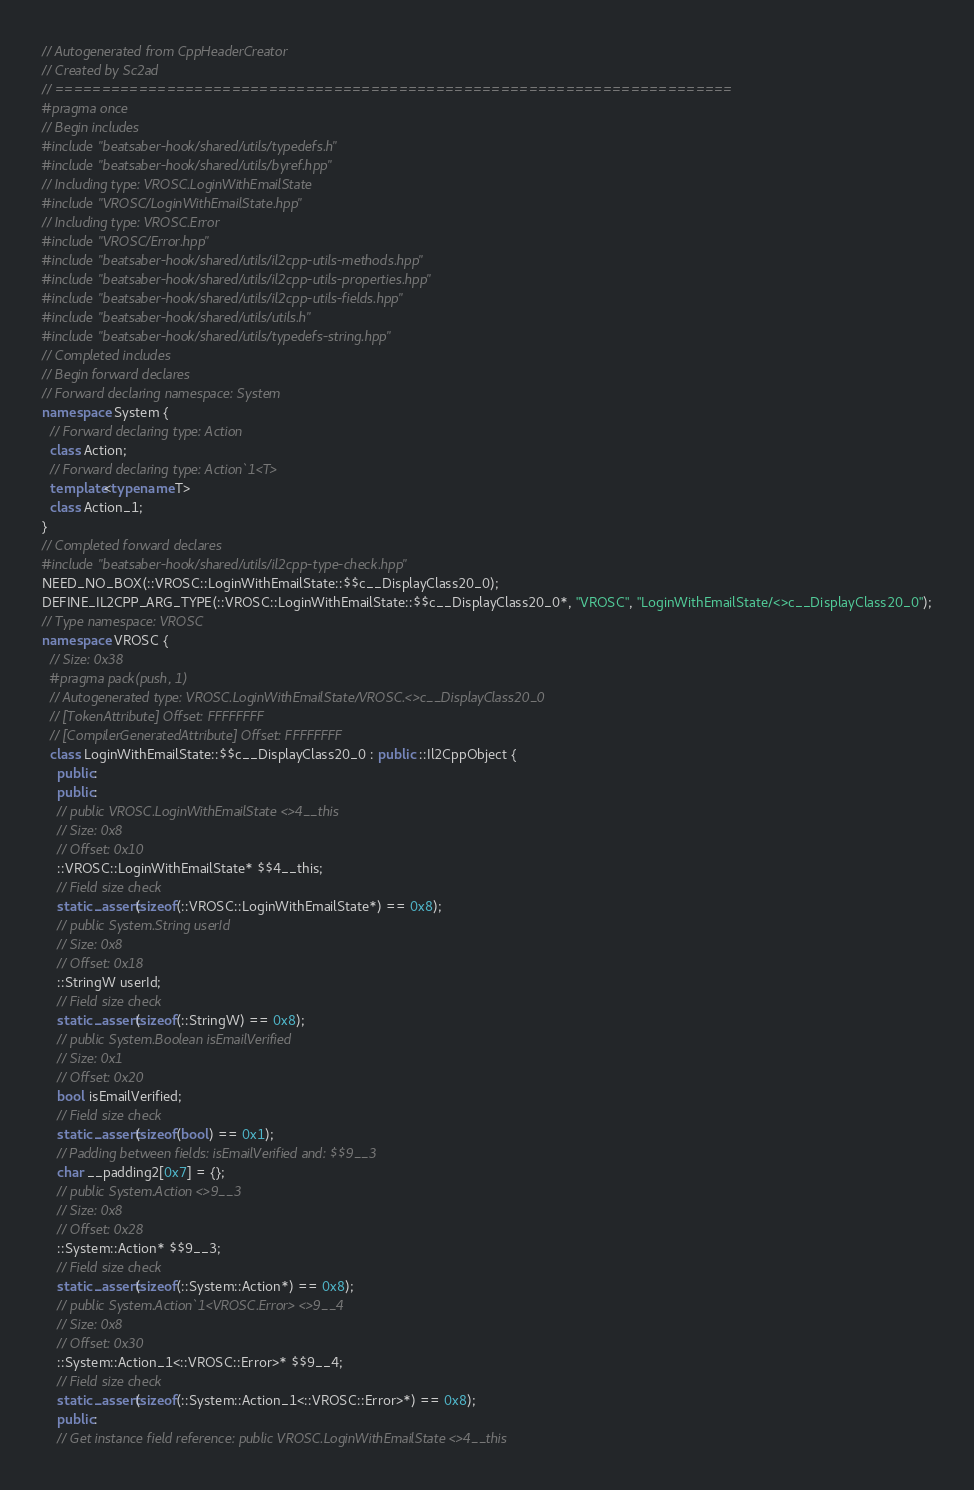<code> <loc_0><loc_0><loc_500><loc_500><_C++_>// Autogenerated from CppHeaderCreator
// Created by Sc2ad
// =========================================================================
#pragma once
// Begin includes
#include "beatsaber-hook/shared/utils/typedefs.h"
#include "beatsaber-hook/shared/utils/byref.hpp"
// Including type: VROSC.LoginWithEmailState
#include "VROSC/LoginWithEmailState.hpp"
// Including type: VROSC.Error
#include "VROSC/Error.hpp"
#include "beatsaber-hook/shared/utils/il2cpp-utils-methods.hpp"
#include "beatsaber-hook/shared/utils/il2cpp-utils-properties.hpp"
#include "beatsaber-hook/shared/utils/il2cpp-utils-fields.hpp"
#include "beatsaber-hook/shared/utils/utils.h"
#include "beatsaber-hook/shared/utils/typedefs-string.hpp"
// Completed includes
// Begin forward declares
// Forward declaring namespace: System
namespace System {
  // Forward declaring type: Action
  class Action;
  // Forward declaring type: Action`1<T>
  template<typename T>
  class Action_1;
}
// Completed forward declares
#include "beatsaber-hook/shared/utils/il2cpp-type-check.hpp"
NEED_NO_BOX(::VROSC::LoginWithEmailState::$$c__DisplayClass20_0);
DEFINE_IL2CPP_ARG_TYPE(::VROSC::LoginWithEmailState::$$c__DisplayClass20_0*, "VROSC", "LoginWithEmailState/<>c__DisplayClass20_0");
// Type namespace: VROSC
namespace VROSC {
  // Size: 0x38
  #pragma pack(push, 1)
  // Autogenerated type: VROSC.LoginWithEmailState/VROSC.<>c__DisplayClass20_0
  // [TokenAttribute] Offset: FFFFFFFF
  // [CompilerGeneratedAttribute] Offset: FFFFFFFF
  class LoginWithEmailState::$$c__DisplayClass20_0 : public ::Il2CppObject {
    public:
    public:
    // public VROSC.LoginWithEmailState <>4__this
    // Size: 0x8
    // Offset: 0x10
    ::VROSC::LoginWithEmailState* $$4__this;
    // Field size check
    static_assert(sizeof(::VROSC::LoginWithEmailState*) == 0x8);
    // public System.String userId
    // Size: 0x8
    // Offset: 0x18
    ::StringW userId;
    // Field size check
    static_assert(sizeof(::StringW) == 0x8);
    // public System.Boolean isEmailVerified
    // Size: 0x1
    // Offset: 0x20
    bool isEmailVerified;
    // Field size check
    static_assert(sizeof(bool) == 0x1);
    // Padding between fields: isEmailVerified and: $$9__3
    char __padding2[0x7] = {};
    // public System.Action <>9__3
    // Size: 0x8
    // Offset: 0x28
    ::System::Action* $$9__3;
    // Field size check
    static_assert(sizeof(::System::Action*) == 0x8);
    // public System.Action`1<VROSC.Error> <>9__4
    // Size: 0x8
    // Offset: 0x30
    ::System::Action_1<::VROSC::Error>* $$9__4;
    // Field size check
    static_assert(sizeof(::System::Action_1<::VROSC::Error>*) == 0x8);
    public:
    // Get instance field reference: public VROSC.LoginWithEmailState <>4__this</code> 